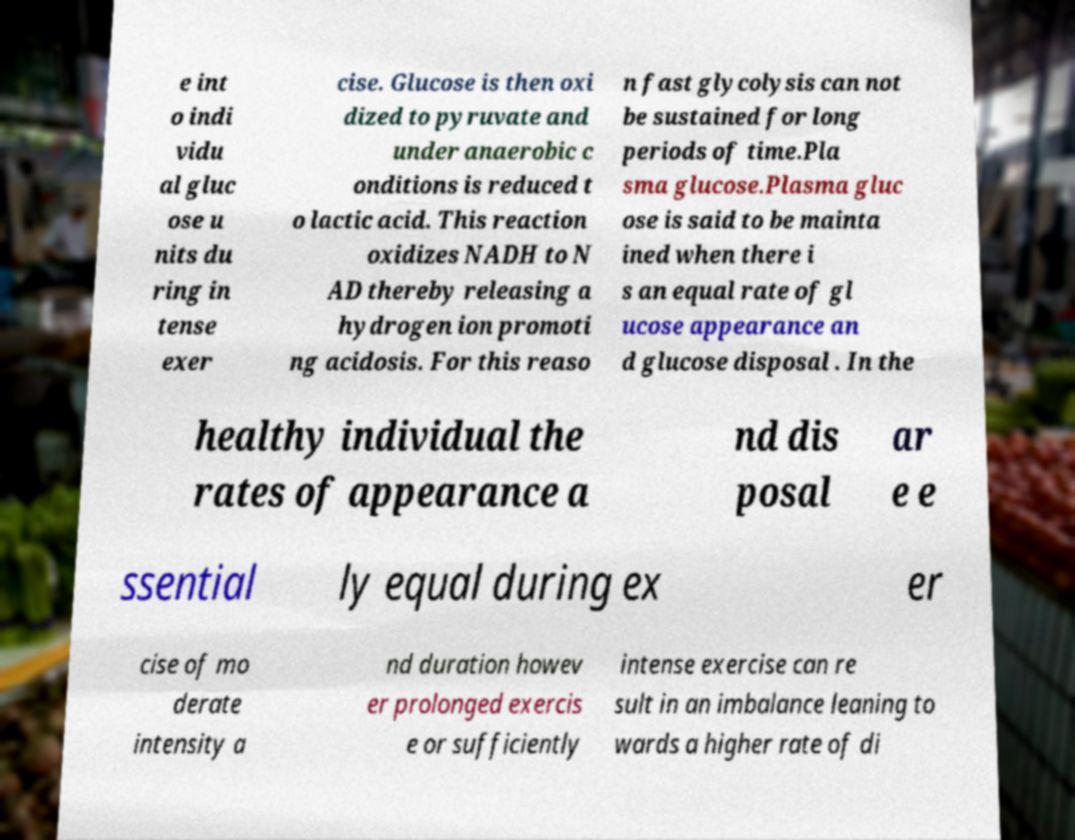Please read and relay the text visible in this image. What does it say? e int o indi vidu al gluc ose u nits du ring in tense exer cise. Glucose is then oxi dized to pyruvate and under anaerobic c onditions is reduced t o lactic acid. This reaction oxidizes NADH to N AD thereby releasing a hydrogen ion promoti ng acidosis. For this reaso n fast glycolysis can not be sustained for long periods of time.Pla sma glucose.Plasma gluc ose is said to be mainta ined when there i s an equal rate of gl ucose appearance an d glucose disposal . In the healthy individual the rates of appearance a nd dis posal ar e e ssential ly equal during ex er cise of mo derate intensity a nd duration howev er prolonged exercis e or sufficiently intense exercise can re sult in an imbalance leaning to wards a higher rate of di 